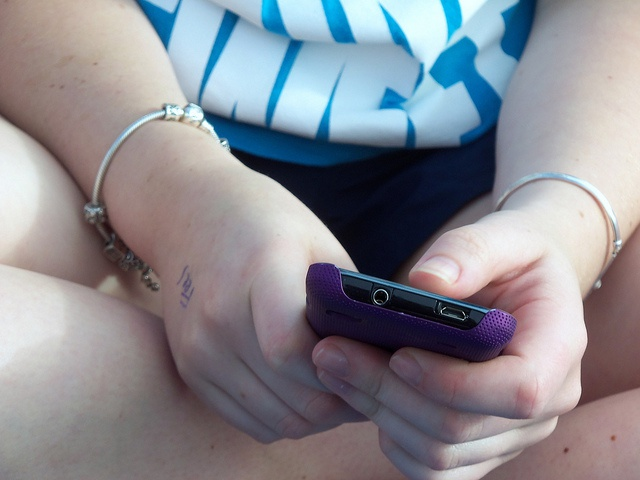Describe the objects in this image and their specific colors. I can see people in darkgray, gray, lightgray, and black tones and cell phone in gray, black, navy, and purple tones in this image. 